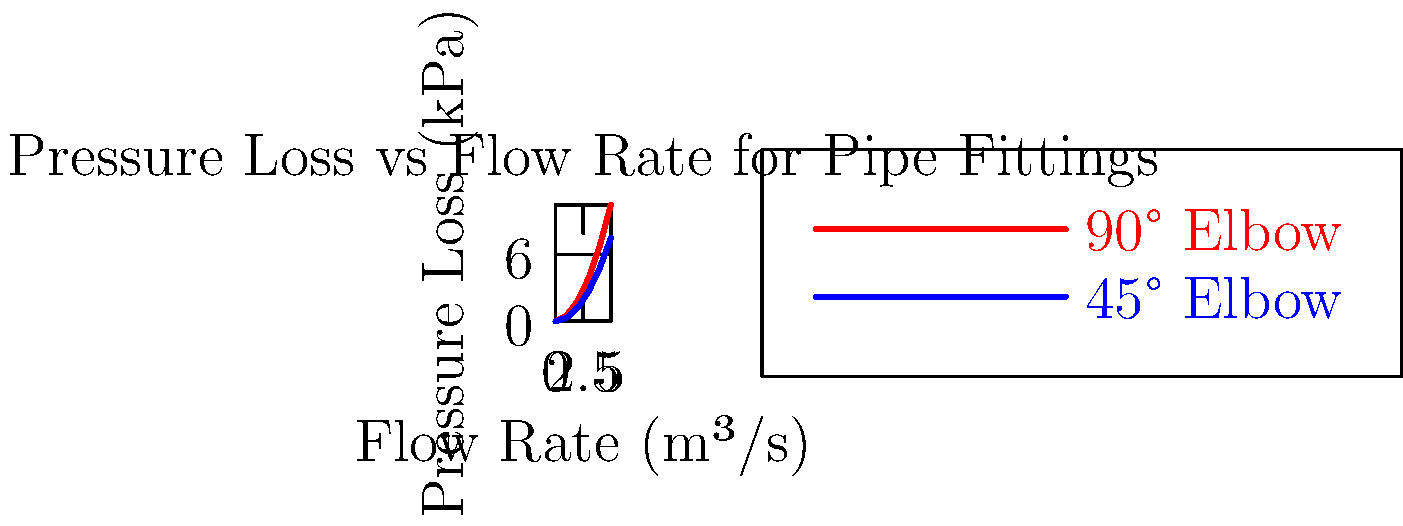Using the graph provided, which shows pressure loss versus flow rate for 90° and 45° elbow pipe fittings, calculate the difference in pressure loss between these two fittings at a flow rate of 4 m³/s. Express your answer in kPa and use regression analysis to determine the most accurate value. To solve this problem, we'll use regression analysis to find the best-fit equations for both curves, then calculate the pressure loss for each fitting at 4 m³/s.

Step 1: Perform regression analysis
Using polynomial regression (quadratic fit), we get:
For 90° elbow: $y = 0.42x^2 + 0.08x$
For 45° elbow: $y = 0.3x^2 + 0.06x$

Step 2: Calculate pressure loss for 90° elbow at 4 m³/s
$y_{90} = 0.42(4)^2 + 0.08(4) = 6.72 + 0.32 = 7.04$ kPa

Step 3: Calculate pressure loss for 45° elbow at 4 m³/s
$y_{45} = 0.3(4)^2 + 0.06(4) = 4.8 + 0.24 = 5.04$ kPa

Step 4: Calculate the difference in pressure loss
Difference = $y_{90} - y_{45} = 7.04 - 5.04 = 2$ kPa

This quantitative approach demonstrates the importance of rigorous mathematical analysis in engineering problems, similar to methods used in economics for data-driven decision making.
Answer: 2 kPa 